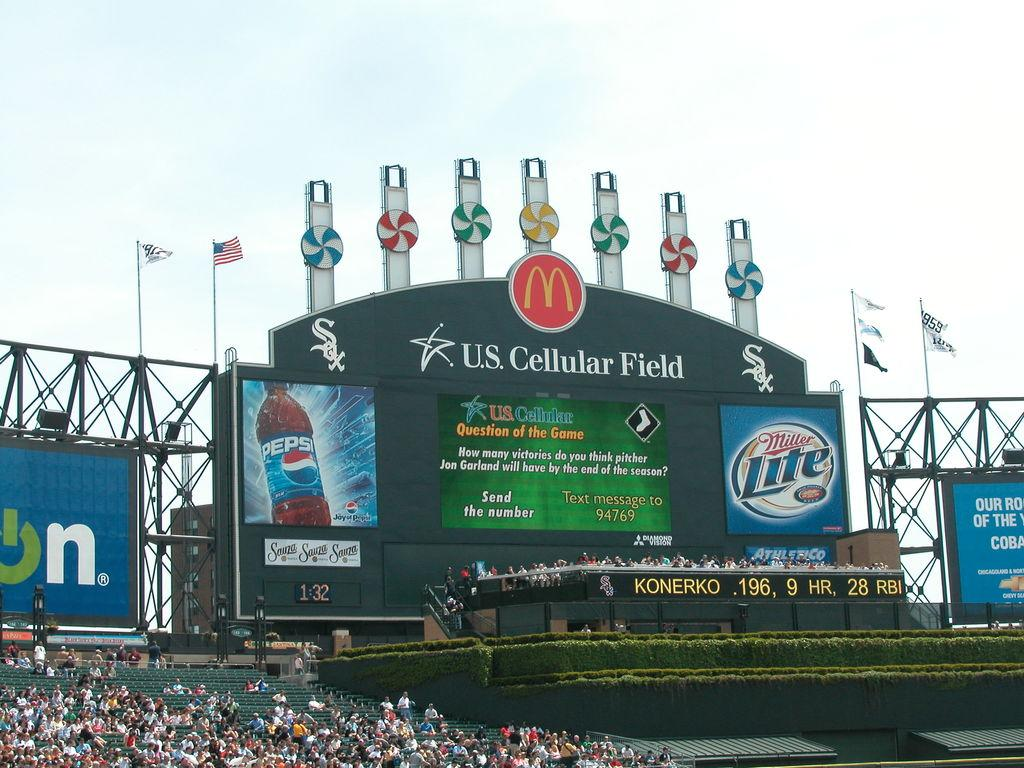<image>
Give a short and clear explanation of the subsequent image. A sign at US Cellular Field with ads for Miller Lite and Pepsi. 